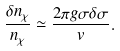Convert formula to latex. <formula><loc_0><loc_0><loc_500><loc_500>\frac { \delta n _ { \chi } } { n _ { \chi } } \simeq \frac { 2 \pi g \sigma \delta \sigma } { v } .</formula> 